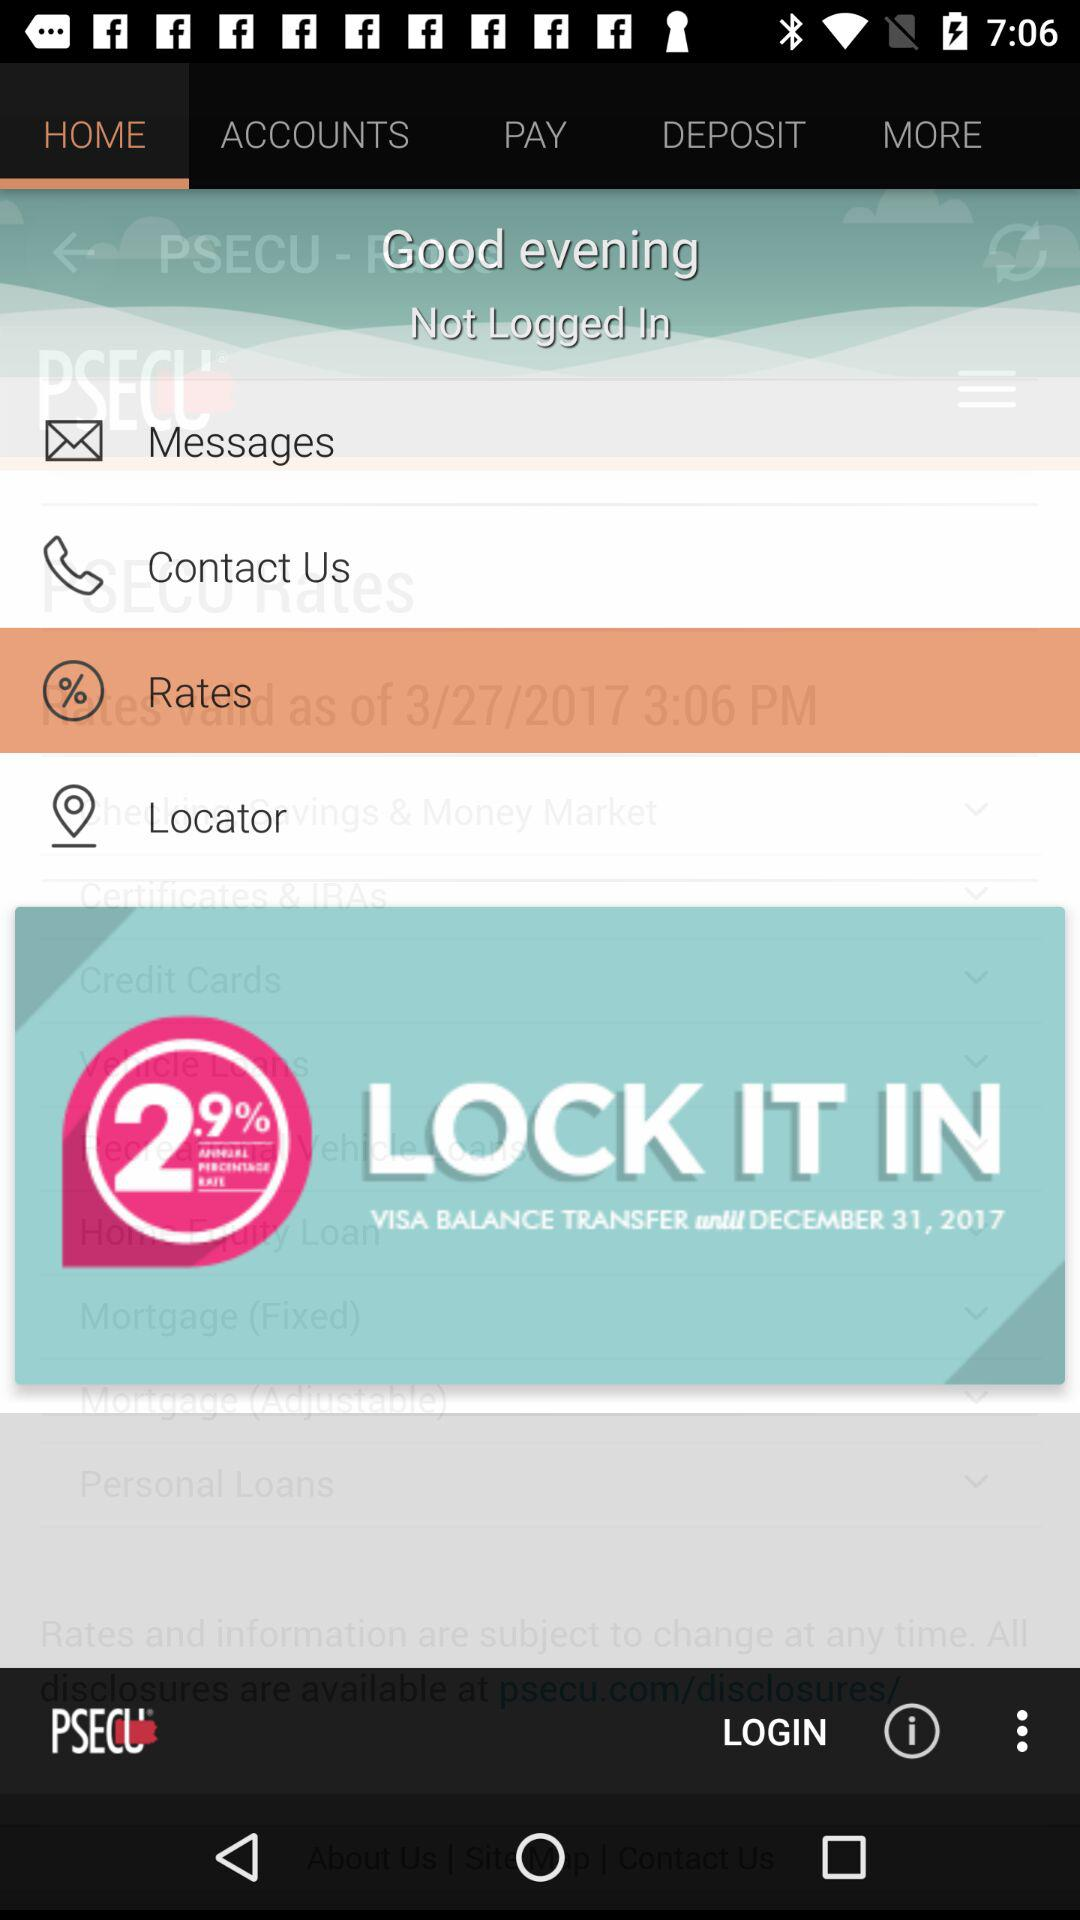What is the selected tab? The selected tab is "HOME". 